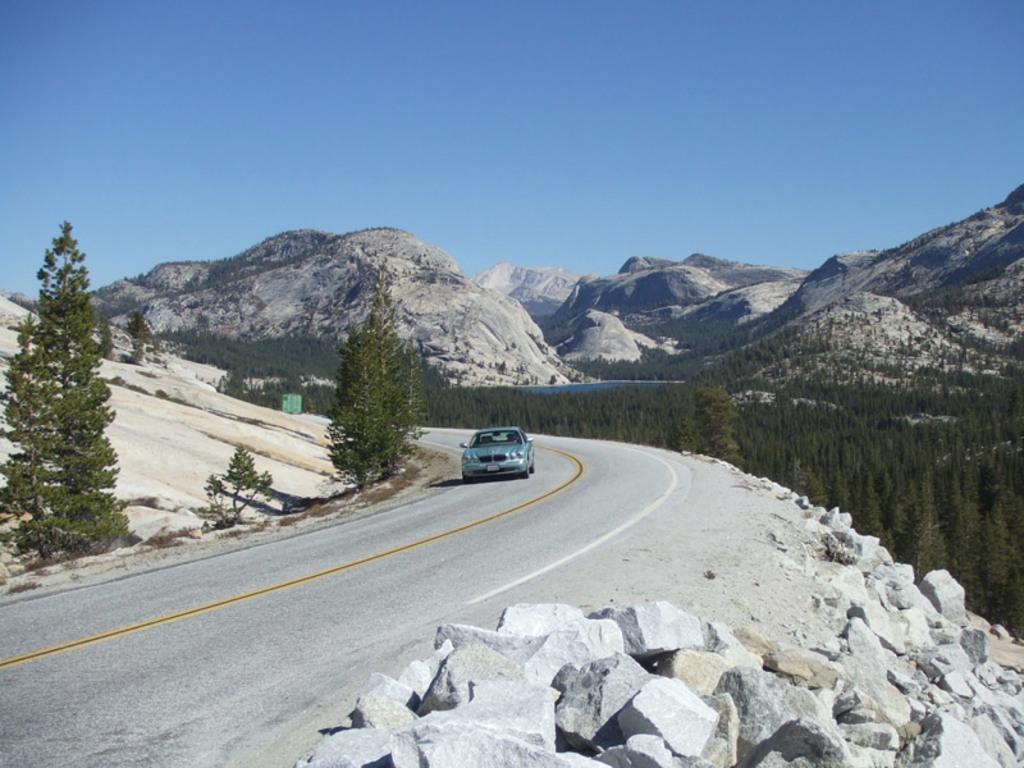How would you summarize this image in a sentence or two? In the center of the image we can see a car on the road. At the bottom we can see rocks. In the background there are trees, hills and sky. 